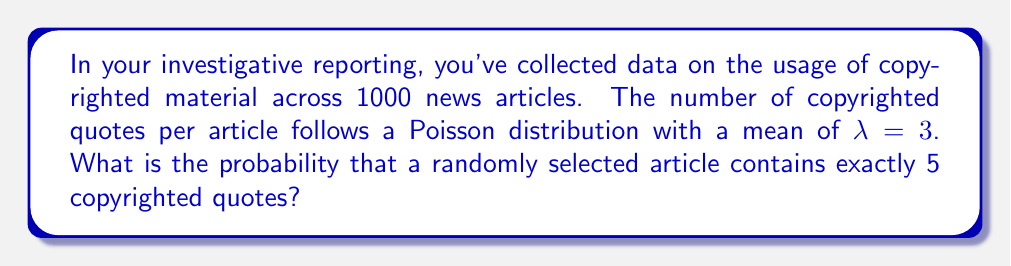Could you help me with this problem? To solve this problem, we'll use the Poisson probability mass function:

$$P(X = k) = \frac{e^{-λ} λ^k}{k!}$$

Where:
- $λ$ is the average number of occurrences (in this case, λ = 3)
- $k$ is the number of occurrences we're interested in (in this case, k = 5)
- $e$ is Euler's number (approximately 2.71828)

Let's solve this step-by-step:

1) Substitute the values into the formula:
   $$P(X = 5) = \frac{e^{-3} 3^5}{5!}$$

2) Calculate $3^5$:
   $$P(X = 5) = \frac{e^{-3} 243}{5!}$$

3) Calculate 5!:
   $$P(X = 5) = \frac{e^{-3} 243}{120}$$

4) Calculate $e^{-3}$ (you can use a calculator for this):
   $$P(X = 5) = \frac{0.0497871 \times 243}{120}$$

5) Multiply the numerator:
   $$P(X = 5) = \frac{12.0982653}{120}$$

6) Divide:
   $$P(X = 5) = 0.1008189$$

7) Round to 4 decimal places:
   $$P(X = 5) ≈ 0.1008$$
Answer: 0.1008 